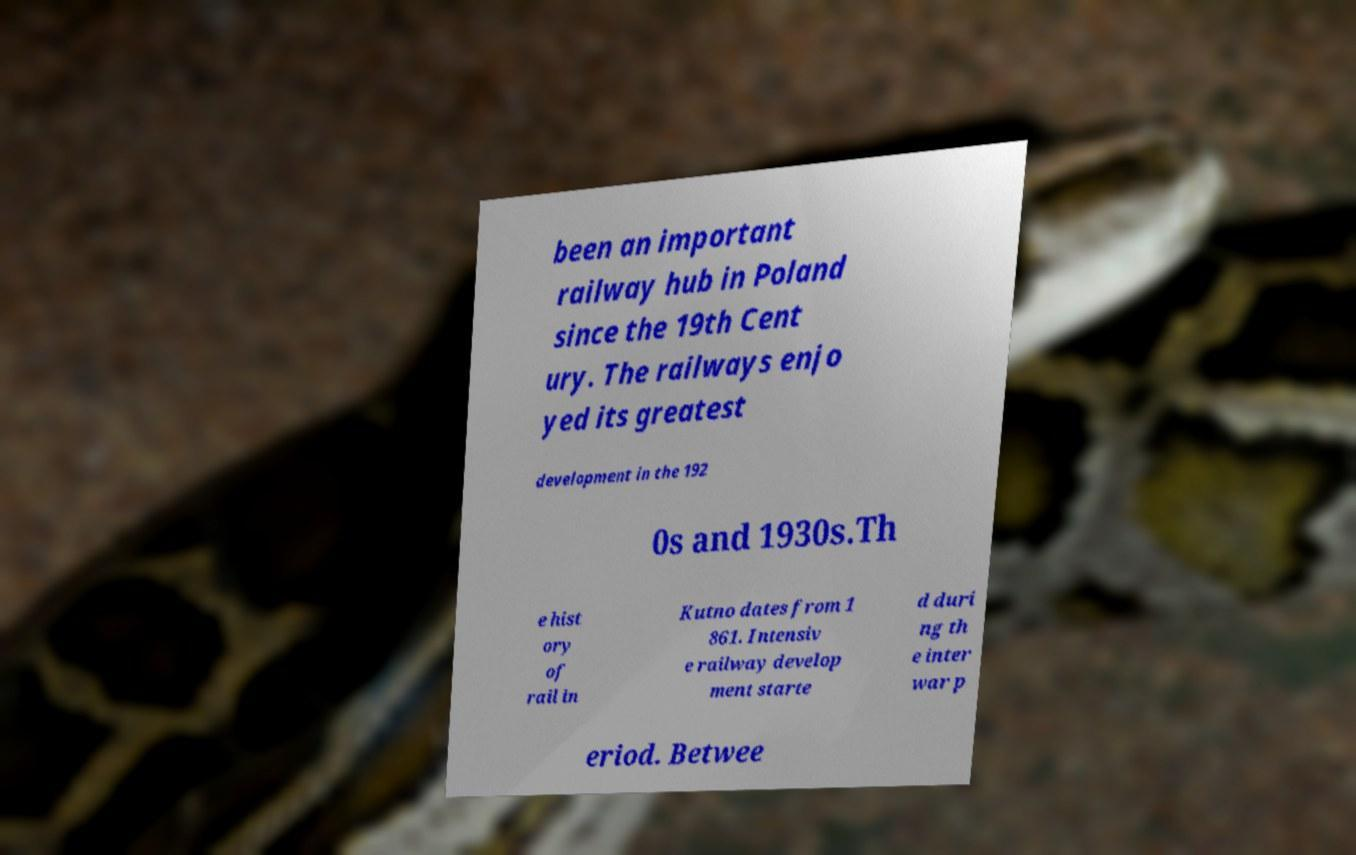Please identify and transcribe the text found in this image. been an important railway hub in Poland since the 19th Cent ury. The railways enjo yed its greatest development in the 192 0s and 1930s.Th e hist ory of rail in Kutno dates from 1 861. Intensiv e railway develop ment starte d duri ng th e inter war p eriod. Betwee 